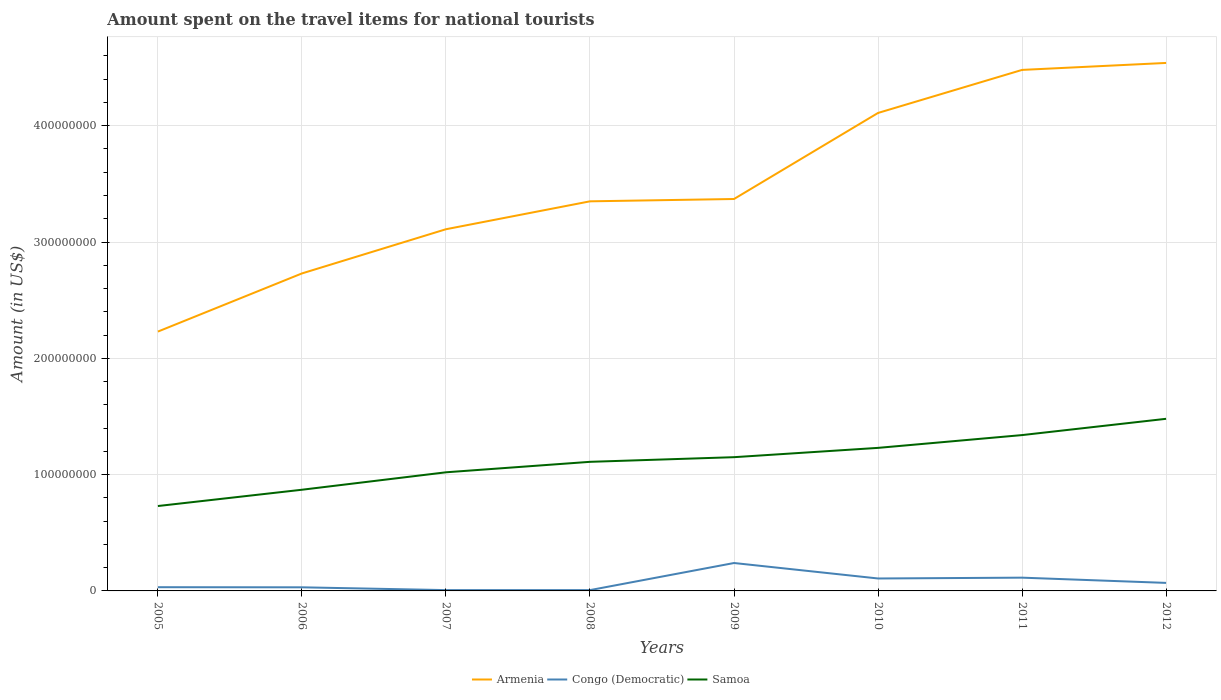How many different coloured lines are there?
Your response must be concise. 3. Does the line corresponding to Armenia intersect with the line corresponding to Congo (Democratic)?
Provide a short and direct response. No. Is the number of lines equal to the number of legend labels?
Give a very brief answer. Yes. Across all years, what is the maximum amount spent on the travel items for national tourists in Samoa?
Your answer should be very brief. 7.30e+07. In which year was the amount spent on the travel items for national tourists in Congo (Democratic) maximum?
Give a very brief answer. 2007. What is the total amount spent on the travel items for national tourists in Armenia in the graph?
Your answer should be very brief. -2.00e+06. What is the difference between the highest and the second highest amount spent on the travel items for national tourists in Armenia?
Offer a terse response. 2.31e+08. What is the difference between two consecutive major ticks on the Y-axis?
Your answer should be compact. 1.00e+08. Are the values on the major ticks of Y-axis written in scientific E-notation?
Offer a terse response. No. Does the graph contain grids?
Make the answer very short. Yes. Where does the legend appear in the graph?
Give a very brief answer. Bottom center. How many legend labels are there?
Your answer should be compact. 3. How are the legend labels stacked?
Your answer should be very brief. Horizontal. What is the title of the graph?
Your answer should be very brief. Amount spent on the travel items for national tourists. What is the label or title of the X-axis?
Your answer should be very brief. Years. What is the label or title of the Y-axis?
Give a very brief answer. Amount (in US$). What is the Amount (in US$) in Armenia in 2005?
Ensure brevity in your answer.  2.23e+08. What is the Amount (in US$) of Congo (Democratic) in 2005?
Provide a short and direct response. 3.20e+06. What is the Amount (in US$) of Samoa in 2005?
Ensure brevity in your answer.  7.30e+07. What is the Amount (in US$) in Armenia in 2006?
Offer a very short reply. 2.73e+08. What is the Amount (in US$) in Congo (Democratic) in 2006?
Your response must be concise. 3.10e+06. What is the Amount (in US$) of Samoa in 2006?
Offer a very short reply. 8.70e+07. What is the Amount (in US$) in Armenia in 2007?
Your answer should be very brief. 3.11e+08. What is the Amount (in US$) in Congo (Democratic) in 2007?
Your response must be concise. 7.00e+05. What is the Amount (in US$) in Samoa in 2007?
Your response must be concise. 1.02e+08. What is the Amount (in US$) of Armenia in 2008?
Offer a terse response. 3.35e+08. What is the Amount (in US$) in Congo (Democratic) in 2008?
Offer a terse response. 7.00e+05. What is the Amount (in US$) in Samoa in 2008?
Provide a short and direct response. 1.11e+08. What is the Amount (in US$) of Armenia in 2009?
Your answer should be compact. 3.37e+08. What is the Amount (in US$) in Congo (Democratic) in 2009?
Your answer should be compact. 2.40e+07. What is the Amount (in US$) of Samoa in 2009?
Offer a very short reply. 1.15e+08. What is the Amount (in US$) in Armenia in 2010?
Ensure brevity in your answer.  4.11e+08. What is the Amount (in US$) of Congo (Democratic) in 2010?
Offer a terse response. 1.07e+07. What is the Amount (in US$) of Samoa in 2010?
Provide a short and direct response. 1.23e+08. What is the Amount (in US$) in Armenia in 2011?
Provide a short and direct response. 4.48e+08. What is the Amount (in US$) in Congo (Democratic) in 2011?
Provide a short and direct response. 1.14e+07. What is the Amount (in US$) in Samoa in 2011?
Give a very brief answer. 1.34e+08. What is the Amount (in US$) in Armenia in 2012?
Ensure brevity in your answer.  4.54e+08. What is the Amount (in US$) of Congo (Democratic) in 2012?
Give a very brief answer. 6.90e+06. What is the Amount (in US$) in Samoa in 2012?
Provide a short and direct response. 1.48e+08. Across all years, what is the maximum Amount (in US$) of Armenia?
Your answer should be very brief. 4.54e+08. Across all years, what is the maximum Amount (in US$) of Congo (Democratic)?
Give a very brief answer. 2.40e+07. Across all years, what is the maximum Amount (in US$) in Samoa?
Your response must be concise. 1.48e+08. Across all years, what is the minimum Amount (in US$) in Armenia?
Keep it short and to the point. 2.23e+08. Across all years, what is the minimum Amount (in US$) in Samoa?
Offer a terse response. 7.30e+07. What is the total Amount (in US$) of Armenia in the graph?
Your response must be concise. 2.79e+09. What is the total Amount (in US$) in Congo (Democratic) in the graph?
Your answer should be compact. 6.07e+07. What is the total Amount (in US$) in Samoa in the graph?
Your response must be concise. 8.93e+08. What is the difference between the Amount (in US$) in Armenia in 2005 and that in 2006?
Keep it short and to the point. -5.00e+07. What is the difference between the Amount (in US$) of Samoa in 2005 and that in 2006?
Make the answer very short. -1.40e+07. What is the difference between the Amount (in US$) in Armenia in 2005 and that in 2007?
Ensure brevity in your answer.  -8.80e+07. What is the difference between the Amount (in US$) of Congo (Democratic) in 2005 and that in 2007?
Offer a terse response. 2.50e+06. What is the difference between the Amount (in US$) in Samoa in 2005 and that in 2007?
Make the answer very short. -2.90e+07. What is the difference between the Amount (in US$) of Armenia in 2005 and that in 2008?
Ensure brevity in your answer.  -1.12e+08. What is the difference between the Amount (in US$) in Congo (Democratic) in 2005 and that in 2008?
Keep it short and to the point. 2.50e+06. What is the difference between the Amount (in US$) of Samoa in 2005 and that in 2008?
Provide a succinct answer. -3.80e+07. What is the difference between the Amount (in US$) of Armenia in 2005 and that in 2009?
Your response must be concise. -1.14e+08. What is the difference between the Amount (in US$) of Congo (Democratic) in 2005 and that in 2009?
Offer a very short reply. -2.08e+07. What is the difference between the Amount (in US$) of Samoa in 2005 and that in 2009?
Ensure brevity in your answer.  -4.20e+07. What is the difference between the Amount (in US$) of Armenia in 2005 and that in 2010?
Ensure brevity in your answer.  -1.88e+08. What is the difference between the Amount (in US$) in Congo (Democratic) in 2005 and that in 2010?
Provide a succinct answer. -7.50e+06. What is the difference between the Amount (in US$) of Samoa in 2005 and that in 2010?
Make the answer very short. -5.00e+07. What is the difference between the Amount (in US$) in Armenia in 2005 and that in 2011?
Give a very brief answer. -2.25e+08. What is the difference between the Amount (in US$) of Congo (Democratic) in 2005 and that in 2011?
Your answer should be compact. -8.20e+06. What is the difference between the Amount (in US$) of Samoa in 2005 and that in 2011?
Provide a short and direct response. -6.10e+07. What is the difference between the Amount (in US$) in Armenia in 2005 and that in 2012?
Provide a succinct answer. -2.31e+08. What is the difference between the Amount (in US$) in Congo (Democratic) in 2005 and that in 2012?
Ensure brevity in your answer.  -3.70e+06. What is the difference between the Amount (in US$) in Samoa in 2005 and that in 2012?
Offer a terse response. -7.50e+07. What is the difference between the Amount (in US$) in Armenia in 2006 and that in 2007?
Offer a very short reply. -3.80e+07. What is the difference between the Amount (in US$) of Congo (Democratic) in 2006 and that in 2007?
Provide a short and direct response. 2.40e+06. What is the difference between the Amount (in US$) of Samoa in 2006 and that in 2007?
Provide a succinct answer. -1.50e+07. What is the difference between the Amount (in US$) in Armenia in 2006 and that in 2008?
Offer a very short reply. -6.20e+07. What is the difference between the Amount (in US$) in Congo (Democratic) in 2006 and that in 2008?
Your answer should be compact. 2.40e+06. What is the difference between the Amount (in US$) in Samoa in 2006 and that in 2008?
Give a very brief answer. -2.40e+07. What is the difference between the Amount (in US$) of Armenia in 2006 and that in 2009?
Ensure brevity in your answer.  -6.40e+07. What is the difference between the Amount (in US$) in Congo (Democratic) in 2006 and that in 2009?
Your response must be concise. -2.09e+07. What is the difference between the Amount (in US$) in Samoa in 2006 and that in 2009?
Your answer should be very brief. -2.80e+07. What is the difference between the Amount (in US$) in Armenia in 2006 and that in 2010?
Keep it short and to the point. -1.38e+08. What is the difference between the Amount (in US$) of Congo (Democratic) in 2006 and that in 2010?
Provide a short and direct response. -7.60e+06. What is the difference between the Amount (in US$) in Samoa in 2006 and that in 2010?
Your answer should be very brief. -3.60e+07. What is the difference between the Amount (in US$) of Armenia in 2006 and that in 2011?
Provide a short and direct response. -1.75e+08. What is the difference between the Amount (in US$) of Congo (Democratic) in 2006 and that in 2011?
Your answer should be very brief. -8.30e+06. What is the difference between the Amount (in US$) in Samoa in 2006 and that in 2011?
Provide a succinct answer. -4.70e+07. What is the difference between the Amount (in US$) in Armenia in 2006 and that in 2012?
Provide a short and direct response. -1.81e+08. What is the difference between the Amount (in US$) in Congo (Democratic) in 2006 and that in 2012?
Provide a succinct answer. -3.80e+06. What is the difference between the Amount (in US$) in Samoa in 2006 and that in 2012?
Your answer should be very brief. -6.10e+07. What is the difference between the Amount (in US$) of Armenia in 2007 and that in 2008?
Offer a terse response. -2.40e+07. What is the difference between the Amount (in US$) in Samoa in 2007 and that in 2008?
Your response must be concise. -9.00e+06. What is the difference between the Amount (in US$) in Armenia in 2007 and that in 2009?
Give a very brief answer. -2.60e+07. What is the difference between the Amount (in US$) in Congo (Democratic) in 2007 and that in 2009?
Provide a succinct answer. -2.33e+07. What is the difference between the Amount (in US$) in Samoa in 2007 and that in 2009?
Offer a terse response. -1.30e+07. What is the difference between the Amount (in US$) of Armenia in 2007 and that in 2010?
Give a very brief answer. -1.00e+08. What is the difference between the Amount (in US$) in Congo (Democratic) in 2007 and that in 2010?
Provide a succinct answer. -1.00e+07. What is the difference between the Amount (in US$) of Samoa in 2007 and that in 2010?
Make the answer very short. -2.10e+07. What is the difference between the Amount (in US$) of Armenia in 2007 and that in 2011?
Offer a very short reply. -1.37e+08. What is the difference between the Amount (in US$) in Congo (Democratic) in 2007 and that in 2011?
Give a very brief answer. -1.07e+07. What is the difference between the Amount (in US$) of Samoa in 2007 and that in 2011?
Give a very brief answer. -3.20e+07. What is the difference between the Amount (in US$) in Armenia in 2007 and that in 2012?
Offer a terse response. -1.43e+08. What is the difference between the Amount (in US$) in Congo (Democratic) in 2007 and that in 2012?
Give a very brief answer. -6.20e+06. What is the difference between the Amount (in US$) in Samoa in 2007 and that in 2012?
Make the answer very short. -4.60e+07. What is the difference between the Amount (in US$) in Congo (Democratic) in 2008 and that in 2009?
Provide a short and direct response. -2.33e+07. What is the difference between the Amount (in US$) in Armenia in 2008 and that in 2010?
Offer a very short reply. -7.60e+07. What is the difference between the Amount (in US$) in Congo (Democratic) in 2008 and that in 2010?
Make the answer very short. -1.00e+07. What is the difference between the Amount (in US$) of Samoa in 2008 and that in 2010?
Provide a succinct answer. -1.20e+07. What is the difference between the Amount (in US$) in Armenia in 2008 and that in 2011?
Ensure brevity in your answer.  -1.13e+08. What is the difference between the Amount (in US$) in Congo (Democratic) in 2008 and that in 2011?
Provide a short and direct response. -1.07e+07. What is the difference between the Amount (in US$) of Samoa in 2008 and that in 2011?
Your response must be concise. -2.30e+07. What is the difference between the Amount (in US$) in Armenia in 2008 and that in 2012?
Give a very brief answer. -1.19e+08. What is the difference between the Amount (in US$) in Congo (Democratic) in 2008 and that in 2012?
Your answer should be compact. -6.20e+06. What is the difference between the Amount (in US$) in Samoa in 2008 and that in 2012?
Your answer should be compact. -3.70e+07. What is the difference between the Amount (in US$) in Armenia in 2009 and that in 2010?
Keep it short and to the point. -7.40e+07. What is the difference between the Amount (in US$) of Congo (Democratic) in 2009 and that in 2010?
Your response must be concise. 1.33e+07. What is the difference between the Amount (in US$) of Samoa in 2009 and that in 2010?
Provide a short and direct response. -8.00e+06. What is the difference between the Amount (in US$) in Armenia in 2009 and that in 2011?
Ensure brevity in your answer.  -1.11e+08. What is the difference between the Amount (in US$) of Congo (Democratic) in 2009 and that in 2011?
Offer a terse response. 1.26e+07. What is the difference between the Amount (in US$) in Samoa in 2009 and that in 2011?
Provide a short and direct response. -1.90e+07. What is the difference between the Amount (in US$) of Armenia in 2009 and that in 2012?
Your answer should be compact. -1.17e+08. What is the difference between the Amount (in US$) in Congo (Democratic) in 2009 and that in 2012?
Keep it short and to the point. 1.71e+07. What is the difference between the Amount (in US$) of Samoa in 2009 and that in 2012?
Keep it short and to the point. -3.30e+07. What is the difference between the Amount (in US$) in Armenia in 2010 and that in 2011?
Keep it short and to the point. -3.70e+07. What is the difference between the Amount (in US$) of Congo (Democratic) in 2010 and that in 2011?
Offer a very short reply. -7.00e+05. What is the difference between the Amount (in US$) of Samoa in 2010 and that in 2011?
Your answer should be very brief. -1.10e+07. What is the difference between the Amount (in US$) in Armenia in 2010 and that in 2012?
Provide a short and direct response. -4.30e+07. What is the difference between the Amount (in US$) in Congo (Democratic) in 2010 and that in 2012?
Make the answer very short. 3.80e+06. What is the difference between the Amount (in US$) of Samoa in 2010 and that in 2012?
Your answer should be very brief. -2.50e+07. What is the difference between the Amount (in US$) in Armenia in 2011 and that in 2012?
Make the answer very short. -6.00e+06. What is the difference between the Amount (in US$) of Congo (Democratic) in 2011 and that in 2012?
Offer a terse response. 4.50e+06. What is the difference between the Amount (in US$) in Samoa in 2011 and that in 2012?
Give a very brief answer. -1.40e+07. What is the difference between the Amount (in US$) in Armenia in 2005 and the Amount (in US$) in Congo (Democratic) in 2006?
Your response must be concise. 2.20e+08. What is the difference between the Amount (in US$) in Armenia in 2005 and the Amount (in US$) in Samoa in 2006?
Offer a terse response. 1.36e+08. What is the difference between the Amount (in US$) of Congo (Democratic) in 2005 and the Amount (in US$) of Samoa in 2006?
Provide a succinct answer. -8.38e+07. What is the difference between the Amount (in US$) of Armenia in 2005 and the Amount (in US$) of Congo (Democratic) in 2007?
Offer a terse response. 2.22e+08. What is the difference between the Amount (in US$) of Armenia in 2005 and the Amount (in US$) of Samoa in 2007?
Provide a short and direct response. 1.21e+08. What is the difference between the Amount (in US$) in Congo (Democratic) in 2005 and the Amount (in US$) in Samoa in 2007?
Offer a terse response. -9.88e+07. What is the difference between the Amount (in US$) in Armenia in 2005 and the Amount (in US$) in Congo (Democratic) in 2008?
Provide a succinct answer. 2.22e+08. What is the difference between the Amount (in US$) of Armenia in 2005 and the Amount (in US$) of Samoa in 2008?
Ensure brevity in your answer.  1.12e+08. What is the difference between the Amount (in US$) in Congo (Democratic) in 2005 and the Amount (in US$) in Samoa in 2008?
Give a very brief answer. -1.08e+08. What is the difference between the Amount (in US$) in Armenia in 2005 and the Amount (in US$) in Congo (Democratic) in 2009?
Offer a very short reply. 1.99e+08. What is the difference between the Amount (in US$) in Armenia in 2005 and the Amount (in US$) in Samoa in 2009?
Your answer should be compact. 1.08e+08. What is the difference between the Amount (in US$) in Congo (Democratic) in 2005 and the Amount (in US$) in Samoa in 2009?
Offer a terse response. -1.12e+08. What is the difference between the Amount (in US$) of Armenia in 2005 and the Amount (in US$) of Congo (Democratic) in 2010?
Offer a very short reply. 2.12e+08. What is the difference between the Amount (in US$) in Armenia in 2005 and the Amount (in US$) in Samoa in 2010?
Keep it short and to the point. 1.00e+08. What is the difference between the Amount (in US$) of Congo (Democratic) in 2005 and the Amount (in US$) of Samoa in 2010?
Offer a very short reply. -1.20e+08. What is the difference between the Amount (in US$) of Armenia in 2005 and the Amount (in US$) of Congo (Democratic) in 2011?
Make the answer very short. 2.12e+08. What is the difference between the Amount (in US$) in Armenia in 2005 and the Amount (in US$) in Samoa in 2011?
Offer a very short reply. 8.90e+07. What is the difference between the Amount (in US$) of Congo (Democratic) in 2005 and the Amount (in US$) of Samoa in 2011?
Provide a succinct answer. -1.31e+08. What is the difference between the Amount (in US$) in Armenia in 2005 and the Amount (in US$) in Congo (Democratic) in 2012?
Provide a succinct answer. 2.16e+08. What is the difference between the Amount (in US$) in Armenia in 2005 and the Amount (in US$) in Samoa in 2012?
Give a very brief answer. 7.50e+07. What is the difference between the Amount (in US$) in Congo (Democratic) in 2005 and the Amount (in US$) in Samoa in 2012?
Give a very brief answer. -1.45e+08. What is the difference between the Amount (in US$) in Armenia in 2006 and the Amount (in US$) in Congo (Democratic) in 2007?
Keep it short and to the point. 2.72e+08. What is the difference between the Amount (in US$) of Armenia in 2006 and the Amount (in US$) of Samoa in 2007?
Your answer should be compact. 1.71e+08. What is the difference between the Amount (in US$) in Congo (Democratic) in 2006 and the Amount (in US$) in Samoa in 2007?
Your response must be concise. -9.89e+07. What is the difference between the Amount (in US$) in Armenia in 2006 and the Amount (in US$) in Congo (Democratic) in 2008?
Make the answer very short. 2.72e+08. What is the difference between the Amount (in US$) in Armenia in 2006 and the Amount (in US$) in Samoa in 2008?
Make the answer very short. 1.62e+08. What is the difference between the Amount (in US$) in Congo (Democratic) in 2006 and the Amount (in US$) in Samoa in 2008?
Give a very brief answer. -1.08e+08. What is the difference between the Amount (in US$) of Armenia in 2006 and the Amount (in US$) of Congo (Democratic) in 2009?
Ensure brevity in your answer.  2.49e+08. What is the difference between the Amount (in US$) in Armenia in 2006 and the Amount (in US$) in Samoa in 2009?
Give a very brief answer. 1.58e+08. What is the difference between the Amount (in US$) in Congo (Democratic) in 2006 and the Amount (in US$) in Samoa in 2009?
Give a very brief answer. -1.12e+08. What is the difference between the Amount (in US$) in Armenia in 2006 and the Amount (in US$) in Congo (Democratic) in 2010?
Keep it short and to the point. 2.62e+08. What is the difference between the Amount (in US$) of Armenia in 2006 and the Amount (in US$) of Samoa in 2010?
Provide a succinct answer. 1.50e+08. What is the difference between the Amount (in US$) in Congo (Democratic) in 2006 and the Amount (in US$) in Samoa in 2010?
Make the answer very short. -1.20e+08. What is the difference between the Amount (in US$) in Armenia in 2006 and the Amount (in US$) in Congo (Democratic) in 2011?
Offer a very short reply. 2.62e+08. What is the difference between the Amount (in US$) of Armenia in 2006 and the Amount (in US$) of Samoa in 2011?
Provide a succinct answer. 1.39e+08. What is the difference between the Amount (in US$) in Congo (Democratic) in 2006 and the Amount (in US$) in Samoa in 2011?
Offer a very short reply. -1.31e+08. What is the difference between the Amount (in US$) in Armenia in 2006 and the Amount (in US$) in Congo (Democratic) in 2012?
Provide a short and direct response. 2.66e+08. What is the difference between the Amount (in US$) in Armenia in 2006 and the Amount (in US$) in Samoa in 2012?
Make the answer very short. 1.25e+08. What is the difference between the Amount (in US$) in Congo (Democratic) in 2006 and the Amount (in US$) in Samoa in 2012?
Keep it short and to the point. -1.45e+08. What is the difference between the Amount (in US$) of Armenia in 2007 and the Amount (in US$) of Congo (Democratic) in 2008?
Your response must be concise. 3.10e+08. What is the difference between the Amount (in US$) in Congo (Democratic) in 2007 and the Amount (in US$) in Samoa in 2008?
Provide a short and direct response. -1.10e+08. What is the difference between the Amount (in US$) of Armenia in 2007 and the Amount (in US$) of Congo (Democratic) in 2009?
Ensure brevity in your answer.  2.87e+08. What is the difference between the Amount (in US$) of Armenia in 2007 and the Amount (in US$) of Samoa in 2009?
Ensure brevity in your answer.  1.96e+08. What is the difference between the Amount (in US$) in Congo (Democratic) in 2007 and the Amount (in US$) in Samoa in 2009?
Your response must be concise. -1.14e+08. What is the difference between the Amount (in US$) in Armenia in 2007 and the Amount (in US$) in Congo (Democratic) in 2010?
Your response must be concise. 3.00e+08. What is the difference between the Amount (in US$) in Armenia in 2007 and the Amount (in US$) in Samoa in 2010?
Keep it short and to the point. 1.88e+08. What is the difference between the Amount (in US$) in Congo (Democratic) in 2007 and the Amount (in US$) in Samoa in 2010?
Offer a very short reply. -1.22e+08. What is the difference between the Amount (in US$) in Armenia in 2007 and the Amount (in US$) in Congo (Democratic) in 2011?
Provide a succinct answer. 3.00e+08. What is the difference between the Amount (in US$) in Armenia in 2007 and the Amount (in US$) in Samoa in 2011?
Offer a very short reply. 1.77e+08. What is the difference between the Amount (in US$) in Congo (Democratic) in 2007 and the Amount (in US$) in Samoa in 2011?
Offer a very short reply. -1.33e+08. What is the difference between the Amount (in US$) in Armenia in 2007 and the Amount (in US$) in Congo (Democratic) in 2012?
Ensure brevity in your answer.  3.04e+08. What is the difference between the Amount (in US$) of Armenia in 2007 and the Amount (in US$) of Samoa in 2012?
Make the answer very short. 1.63e+08. What is the difference between the Amount (in US$) of Congo (Democratic) in 2007 and the Amount (in US$) of Samoa in 2012?
Ensure brevity in your answer.  -1.47e+08. What is the difference between the Amount (in US$) in Armenia in 2008 and the Amount (in US$) in Congo (Democratic) in 2009?
Offer a very short reply. 3.11e+08. What is the difference between the Amount (in US$) of Armenia in 2008 and the Amount (in US$) of Samoa in 2009?
Provide a short and direct response. 2.20e+08. What is the difference between the Amount (in US$) of Congo (Democratic) in 2008 and the Amount (in US$) of Samoa in 2009?
Offer a terse response. -1.14e+08. What is the difference between the Amount (in US$) in Armenia in 2008 and the Amount (in US$) in Congo (Democratic) in 2010?
Give a very brief answer. 3.24e+08. What is the difference between the Amount (in US$) of Armenia in 2008 and the Amount (in US$) of Samoa in 2010?
Keep it short and to the point. 2.12e+08. What is the difference between the Amount (in US$) in Congo (Democratic) in 2008 and the Amount (in US$) in Samoa in 2010?
Offer a terse response. -1.22e+08. What is the difference between the Amount (in US$) of Armenia in 2008 and the Amount (in US$) of Congo (Democratic) in 2011?
Provide a short and direct response. 3.24e+08. What is the difference between the Amount (in US$) in Armenia in 2008 and the Amount (in US$) in Samoa in 2011?
Your answer should be compact. 2.01e+08. What is the difference between the Amount (in US$) in Congo (Democratic) in 2008 and the Amount (in US$) in Samoa in 2011?
Give a very brief answer. -1.33e+08. What is the difference between the Amount (in US$) of Armenia in 2008 and the Amount (in US$) of Congo (Democratic) in 2012?
Provide a succinct answer. 3.28e+08. What is the difference between the Amount (in US$) in Armenia in 2008 and the Amount (in US$) in Samoa in 2012?
Provide a succinct answer. 1.87e+08. What is the difference between the Amount (in US$) of Congo (Democratic) in 2008 and the Amount (in US$) of Samoa in 2012?
Keep it short and to the point. -1.47e+08. What is the difference between the Amount (in US$) of Armenia in 2009 and the Amount (in US$) of Congo (Democratic) in 2010?
Offer a terse response. 3.26e+08. What is the difference between the Amount (in US$) in Armenia in 2009 and the Amount (in US$) in Samoa in 2010?
Keep it short and to the point. 2.14e+08. What is the difference between the Amount (in US$) of Congo (Democratic) in 2009 and the Amount (in US$) of Samoa in 2010?
Your response must be concise. -9.90e+07. What is the difference between the Amount (in US$) of Armenia in 2009 and the Amount (in US$) of Congo (Democratic) in 2011?
Offer a very short reply. 3.26e+08. What is the difference between the Amount (in US$) of Armenia in 2009 and the Amount (in US$) of Samoa in 2011?
Your response must be concise. 2.03e+08. What is the difference between the Amount (in US$) of Congo (Democratic) in 2009 and the Amount (in US$) of Samoa in 2011?
Provide a short and direct response. -1.10e+08. What is the difference between the Amount (in US$) in Armenia in 2009 and the Amount (in US$) in Congo (Democratic) in 2012?
Provide a succinct answer. 3.30e+08. What is the difference between the Amount (in US$) in Armenia in 2009 and the Amount (in US$) in Samoa in 2012?
Offer a very short reply. 1.89e+08. What is the difference between the Amount (in US$) in Congo (Democratic) in 2009 and the Amount (in US$) in Samoa in 2012?
Your response must be concise. -1.24e+08. What is the difference between the Amount (in US$) in Armenia in 2010 and the Amount (in US$) in Congo (Democratic) in 2011?
Ensure brevity in your answer.  4.00e+08. What is the difference between the Amount (in US$) of Armenia in 2010 and the Amount (in US$) of Samoa in 2011?
Give a very brief answer. 2.77e+08. What is the difference between the Amount (in US$) in Congo (Democratic) in 2010 and the Amount (in US$) in Samoa in 2011?
Offer a very short reply. -1.23e+08. What is the difference between the Amount (in US$) in Armenia in 2010 and the Amount (in US$) in Congo (Democratic) in 2012?
Ensure brevity in your answer.  4.04e+08. What is the difference between the Amount (in US$) in Armenia in 2010 and the Amount (in US$) in Samoa in 2012?
Ensure brevity in your answer.  2.63e+08. What is the difference between the Amount (in US$) in Congo (Democratic) in 2010 and the Amount (in US$) in Samoa in 2012?
Your answer should be compact. -1.37e+08. What is the difference between the Amount (in US$) in Armenia in 2011 and the Amount (in US$) in Congo (Democratic) in 2012?
Provide a succinct answer. 4.41e+08. What is the difference between the Amount (in US$) in Armenia in 2011 and the Amount (in US$) in Samoa in 2012?
Your answer should be compact. 3.00e+08. What is the difference between the Amount (in US$) of Congo (Democratic) in 2011 and the Amount (in US$) of Samoa in 2012?
Your response must be concise. -1.37e+08. What is the average Amount (in US$) in Armenia per year?
Your answer should be compact. 3.49e+08. What is the average Amount (in US$) of Congo (Democratic) per year?
Provide a short and direct response. 7.59e+06. What is the average Amount (in US$) in Samoa per year?
Give a very brief answer. 1.12e+08. In the year 2005, what is the difference between the Amount (in US$) of Armenia and Amount (in US$) of Congo (Democratic)?
Your answer should be compact. 2.20e+08. In the year 2005, what is the difference between the Amount (in US$) in Armenia and Amount (in US$) in Samoa?
Your response must be concise. 1.50e+08. In the year 2005, what is the difference between the Amount (in US$) of Congo (Democratic) and Amount (in US$) of Samoa?
Your answer should be very brief. -6.98e+07. In the year 2006, what is the difference between the Amount (in US$) of Armenia and Amount (in US$) of Congo (Democratic)?
Keep it short and to the point. 2.70e+08. In the year 2006, what is the difference between the Amount (in US$) of Armenia and Amount (in US$) of Samoa?
Offer a terse response. 1.86e+08. In the year 2006, what is the difference between the Amount (in US$) in Congo (Democratic) and Amount (in US$) in Samoa?
Provide a short and direct response. -8.39e+07. In the year 2007, what is the difference between the Amount (in US$) of Armenia and Amount (in US$) of Congo (Democratic)?
Your answer should be compact. 3.10e+08. In the year 2007, what is the difference between the Amount (in US$) in Armenia and Amount (in US$) in Samoa?
Your response must be concise. 2.09e+08. In the year 2007, what is the difference between the Amount (in US$) of Congo (Democratic) and Amount (in US$) of Samoa?
Ensure brevity in your answer.  -1.01e+08. In the year 2008, what is the difference between the Amount (in US$) of Armenia and Amount (in US$) of Congo (Democratic)?
Your answer should be compact. 3.34e+08. In the year 2008, what is the difference between the Amount (in US$) in Armenia and Amount (in US$) in Samoa?
Give a very brief answer. 2.24e+08. In the year 2008, what is the difference between the Amount (in US$) in Congo (Democratic) and Amount (in US$) in Samoa?
Give a very brief answer. -1.10e+08. In the year 2009, what is the difference between the Amount (in US$) of Armenia and Amount (in US$) of Congo (Democratic)?
Offer a very short reply. 3.13e+08. In the year 2009, what is the difference between the Amount (in US$) of Armenia and Amount (in US$) of Samoa?
Ensure brevity in your answer.  2.22e+08. In the year 2009, what is the difference between the Amount (in US$) in Congo (Democratic) and Amount (in US$) in Samoa?
Give a very brief answer. -9.10e+07. In the year 2010, what is the difference between the Amount (in US$) of Armenia and Amount (in US$) of Congo (Democratic)?
Provide a succinct answer. 4.00e+08. In the year 2010, what is the difference between the Amount (in US$) of Armenia and Amount (in US$) of Samoa?
Your response must be concise. 2.88e+08. In the year 2010, what is the difference between the Amount (in US$) in Congo (Democratic) and Amount (in US$) in Samoa?
Provide a short and direct response. -1.12e+08. In the year 2011, what is the difference between the Amount (in US$) of Armenia and Amount (in US$) of Congo (Democratic)?
Ensure brevity in your answer.  4.37e+08. In the year 2011, what is the difference between the Amount (in US$) in Armenia and Amount (in US$) in Samoa?
Your response must be concise. 3.14e+08. In the year 2011, what is the difference between the Amount (in US$) of Congo (Democratic) and Amount (in US$) of Samoa?
Provide a succinct answer. -1.23e+08. In the year 2012, what is the difference between the Amount (in US$) in Armenia and Amount (in US$) in Congo (Democratic)?
Make the answer very short. 4.47e+08. In the year 2012, what is the difference between the Amount (in US$) in Armenia and Amount (in US$) in Samoa?
Give a very brief answer. 3.06e+08. In the year 2012, what is the difference between the Amount (in US$) of Congo (Democratic) and Amount (in US$) of Samoa?
Make the answer very short. -1.41e+08. What is the ratio of the Amount (in US$) of Armenia in 2005 to that in 2006?
Give a very brief answer. 0.82. What is the ratio of the Amount (in US$) of Congo (Democratic) in 2005 to that in 2006?
Offer a terse response. 1.03. What is the ratio of the Amount (in US$) in Samoa in 2005 to that in 2006?
Provide a succinct answer. 0.84. What is the ratio of the Amount (in US$) of Armenia in 2005 to that in 2007?
Offer a very short reply. 0.72. What is the ratio of the Amount (in US$) in Congo (Democratic) in 2005 to that in 2007?
Your answer should be compact. 4.57. What is the ratio of the Amount (in US$) in Samoa in 2005 to that in 2007?
Make the answer very short. 0.72. What is the ratio of the Amount (in US$) of Armenia in 2005 to that in 2008?
Your response must be concise. 0.67. What is the ratio of the Amount (in US$) of Congo (Democratic) in 2005 to that in 2008?
Ensure brevity in your answer.  4.57. What is the ratio of the Amount (in US$) of Samoa in 2005 to that in 2008?
Offer a terse response. 0.66. What is the ratio of the Amount (in US$) of Armenia in 2005 to that in 2009?
Make the answer very short. 0.66. What is the ratio of the Amount (in US$) in Congo (Democratic) in 2005 to that in 2009?
Keep it short and to the point. 0.13. What is the ratio of the Amount (in US$) of Samoa in 2005 to that in 2009?
Offer a very short reply. 0.63. What is the ratio of the Amount (in US$) of Armenia in 2005 to that in 2010?
Your response must be concise. 0.54. What is the ratio of the Amount (in US$) of Congo (Democratic) in 2005 to that in 2010?
Your response must be concise. 0.3. What is the ratio of the Amount (in US$) in Samoa in 2005 to that in 2010?
Keep it short and to the point. 0.59. What is the ratio of the Amount (in US$) of Armenia in 2005 to that in 2011?
Provide a short and direct response. 0.5. What is the ratio of the Amount (in US$) of Congo (Democratic) in 2005 to that in 2011?
Offer a very short reply. 0.28. What is the ratio of the Amount (in US$) in Samoa in 2005 to that in 2011?
Offer a terse response. 0.54. What is the ratio of the Amount (in US$) in Armenia in 2005 to that in 2012?
Your answer should be very brief. 0.49. What is the ratio of the Amount (in US$) in Congo (Democratic) in 2005 to that in 2012?
Make the answer very short. 0.46. What is the ratio of the Amount (in US$) of Samoa in 2005 to that in 2012?
Ensure brevity in your answer.  0.49. What is the ratio of the Amount (in US$) in Armenia in 2006 to that in 2007?
Keep it short and to the point. 0.88. What is the ratio of the Amount (in US$) of Congo (Democratic) in 2006 to that in 2007?
Make the answer very short. 4.43. What is the ratio of the Amount (in US$) of Samoa in 2006 to that in 2007?
Keep it short and to the point. 0.85. What is the ratio of the Amount (in US$) of Armenia in 2006 to that in 2008?
Provide a succinct answer. 0.81. What is the ratio of the Amount (in US$) in Congo (Democratic) in 2006 to that in 2008?
Provide a succinct answer. 4.43. What is the ratio of the Amount (in US$) in Samoa in 2006 to that in 2008?
Ensure brevity in your answer.  0.78. What is the ratio of the Amount (in US$) in Armenia in 2006 to that in 2009?
Provide a succinct answer. 0.81. What is the ratio of the Amount (in US$) in Congo (Democratic) in 2006 to that in 2009?
Your response must be concise. 0.13. What is the ratio of the Amount (in US$) of Samoa in 2006 to that in 2009?
Provide a short and direct response. 0.76. What is the ratio of the Amount (in US$) of Armenia in 2006 to that in 2010?
Your answer should be very brief. 0.66. What is the ratio of the Amount (in US$) of Congo (Democratic) in 2006 to that in 2010?
Your response must be concise. 0.29. What is the ratio of the Amount (in US$) of Samoa in 2006 to that in 2010?
Your response must be concise. 0.71. What is the ratio of the Amount (in US$) in Armenia in 2006 to that in 2011?
Your answer should be compact. 0.61. What is the ratio of the Amount (in US$) in Congo (Democratic) in 2006 to that in 2011?
Provide a short and direct response. 0.27. What is the ratio of the Amount (in US$) in Samoa in 2006 to that in 2011?
Offer a terse response. 0.65. What is the ratio of the Amount (in US$) in Armenia in 2006 to that in 2012?
Offer a terse response. 0.6. What is the ratio of the Amount (in US$) in Congo (Democratic) in 2006 to that in 2012?
Offer a very short reply. 0.45. What is the ratio of the Amount (in US$) of Samoa in 2006 to that in 2012?
Ensure brevity in your answer.  0.59. What is the ratio of the Amount (in US$) in Armenia in 2007 to that in 2008?
Your response must be concise. 0.93. What is the ratio of the Amount (in US$) of Congo (Democratic) in 2007 to that in 2008?
Your answer should be compact. 1. What is the ratio of the Amount (in US$) in Samoa in 2007 to that in 2008?
Keep it short and to the point. 0.92. What is the ratio of the Amount (in US$) in Armenia in 2007 to that in 2009?
Give a very brief answer. 0.92. What is the ratio of the Amount (in US$) in Congo (Democratic) in 2007 to that in 2009?
Offer a terse response. 0.03. What is the ratio of the Amount (in US$) of Samoa in 2007 to that in 2009?
Make the answer very short. 0.89. What is the ratio of the Amount (in US$) in Armenia in 2007 to that in 2010?
Provide a succinct answer. 0.76. What is the ratio of the Amount (in US$) of Congo (Democratic) in 2007 to that in 2010?
Provide a succinct answer. 0.07. What is the ratio of the Amount (in US$) in Samoa in 2007 to that in 2010?
Your answer should be compact. 0.83. What is the ratio of the Amount (in US$) of Armenia in 2007 to that in 2011?
Make the answer very short. 0.69. What is the ratio of the Amount (in US$) of Congo (Democratic) in 2007 to that in 2011?
Your answer should be compact. 0.06. What is the ratio of the Amount (in US$) of Samoa in 2007 to that in 2011?
Provide a short and direct response. 0.76. What is the ratio of the Amount (in US$) of Armenia in 2007 to that in 2012?
Ensure brevity in your answer.  0.69. What is the ratio of the Amount (in US$) of Congo (Democratic) in 2007 to that in 2012?
Make the answer very short. 0.1. What is the ratio of the Amount (in US$) in Samoa in 2007 to that in 2012?
Your response must be concise. 0.69. What is the ratio of the Amount (in US$) of Armenia in 2008 to that in 2009?
Make the answer very short. 0.99. What is the ratio of the Amount (in US$) in Congo (Democratic) in 2008 to that in 2009?
Give a very brief answer. 0.03. What is the ratio of the Amount (in US$) in Samoa in 2008 to that in 2009?
Ensure brevity in your answer.  0.97. What is the ratio of the Amount (in US$) in Armenia in 2008 to that in 2010?
Offer a terse response. 0.82. What is the ratio of the Amount (in US$) in Congo (Democratic) in 2008 to that in 2010?
Give a very brief answer. 0.07. What is the ratio of the Amount (in US$) of Samoa in 2008 to that in 2010?
Your answer should be compact. 0.9. What is the ratio of the Amount (in US$) of Armenia in 2008 to that in 2011?
Give a very brief answer. 0.75. What is the ratio of the Amount (in US$) in Congo (Democratic) in 2008 to that in 2011?
Your response must be concise. 0.06. What is the ratio of the Amount (in US$) of Samoa in 2008 to that in 2011?
Ensure brevity in your answer.  0.83. What is the ratio of the Amount (in US$) in Armenia in 2008 to that in 2012?
Keep it short and to the point. 0.74. What is the ratio of the Amount (in US$) in Congo (Democratic) in 2008 to that in 2012?
Your answer should be very brief. 0.1. What is the ratio of the Amount (in US$) in Armenia in 2009 to that in 2010?
Offer a very short reply. 0.82. What is the ratio of the Amount (in US$) in Congo (Democratic) in 2009 to that in 2010?
Keep it short and to the point. 2.24. What is the ratio of the Amount (in US$) of Samoa in 2009 to that in 2010?
Keep it short and to the point. 0.94. What is the ratio of the Amount (in US$) of Armenia in 2009 to that in 2011?
Make the answer very short. 0.75. What is the ratio of the Amount (in US$) in Congo (Democratic) in 2009 to that in 2011?
Offer a terse response. 2.11. What is the ratio of the Amount (in US$) in Samoa in 2009 to that in 2011?
Your response must be concise. 0.86. What is the ratio of the Amount (in US$) in Armenia in 2009 to that in 2012?
Offer a terse response. 0.74. What is the ratio of the Amount (in US$) in Congo (Democratic) in 2009 to that in 2012?
Your response must be concise. 3.48. What is the ratio of the Amount (in US$) in Samoa in 2009 to that in 2012?
Provide a succinct answer. 0.78. What is the ratio of the Amount (in US$) of Armenia in 2010 to that in 2011?
Offer a very short reply. 0.92. What is the ratio of the Amount (in US$) of Congo (Democratic) in 2010 to that in 2011?
Ensure brevity in your answer.  0.94. What is the ratio of the Amount (in US$) of Samoa in 2010 to that in 2011?
Your answer should be compact. 0.92. What is the ratio of the Amount (in US$) in Armenia in 2010 to that in 2012?
Provide a succinct answer. 0.91. What is the ratio of the Amount (in US$) in Congo (Democratic) in 2010 to that in 2012?
Your response must be concise. 1.55. What is the ratio of the Amount (in US$) of Samoa in 2010 to that in 2012?
Offer a very short reply. 0.83. What is the ratio of the Amount (in US$) in Armenia in 2011 to that in 2012?
Offer a terse response. 0.99. What is the ratio of the Amount (in US$) in Congo (Democratic) in 2011 to that in 2012?
Ensure brevity in your answer.  1.65. What is the ratio of the Amount (in US$) of Samoa in 2011 to that in 2012?
Give a very brief answer. 0.91. What is the difference between the highest and the second highest Amount (in US$) in Armenia?
Provide a short and direct response. 6.00e+06. What is the difference between the highest and the second highest Amount (in US$) of Congo (Democratic)?
Your answer should be very brief. 1.26e+07. What is the difference between the highest and the second highest Amount (in US$) of Samoa?
Provide a short and direct response. 1.40e+07. What is the difference between the highest and the lowest Amount (in US$) in Armenia?
Offer a terse response. 2.31e+08. What is the difference between the highest and the lowest Amount (in US$) in Congo (Democratic)?
Ensure brevity in your answer.  2.33e+07. What is the difference between the highest and the lowest Amount (in US$) of Samoa?
Give a very brief answer. 7.50e+07. 